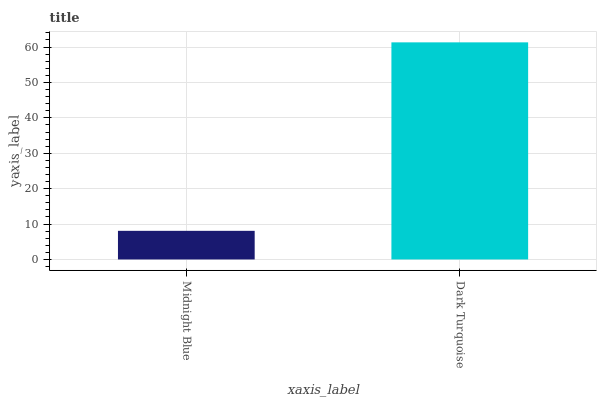Is Dark Turquoise the minimum?
Answer yes or no. No. Is Dark Turquoise greater than Midnight Blue?
Answer yes or no. Yes. Is Midnight Blue less than Dark Turquoise?
Answer yes or no. Yes. Is Midnight Blue greater than Dark Turquoise?
Answer yes or no. No. Is Dark Turquoise less than Midnight Blue?
Answer yes or no. No. Is Dark Turquoise the high median?
Answer yes or no. Yes. Is Midnight Blue the low median?
Answer yes or no. Yes. Is Midnight Blue the high median?
Answer yes or no. No. Is Dark Turquoise the low median?
Answer yes or no. No. 